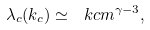Convert formula to latex. <formula><loc_0><loc_0><loc_500><loc_500>\lambda _ { c } ( k _ { c } ) \simeq \ k c m ^ { \gamma - 3 } ,</formula> 